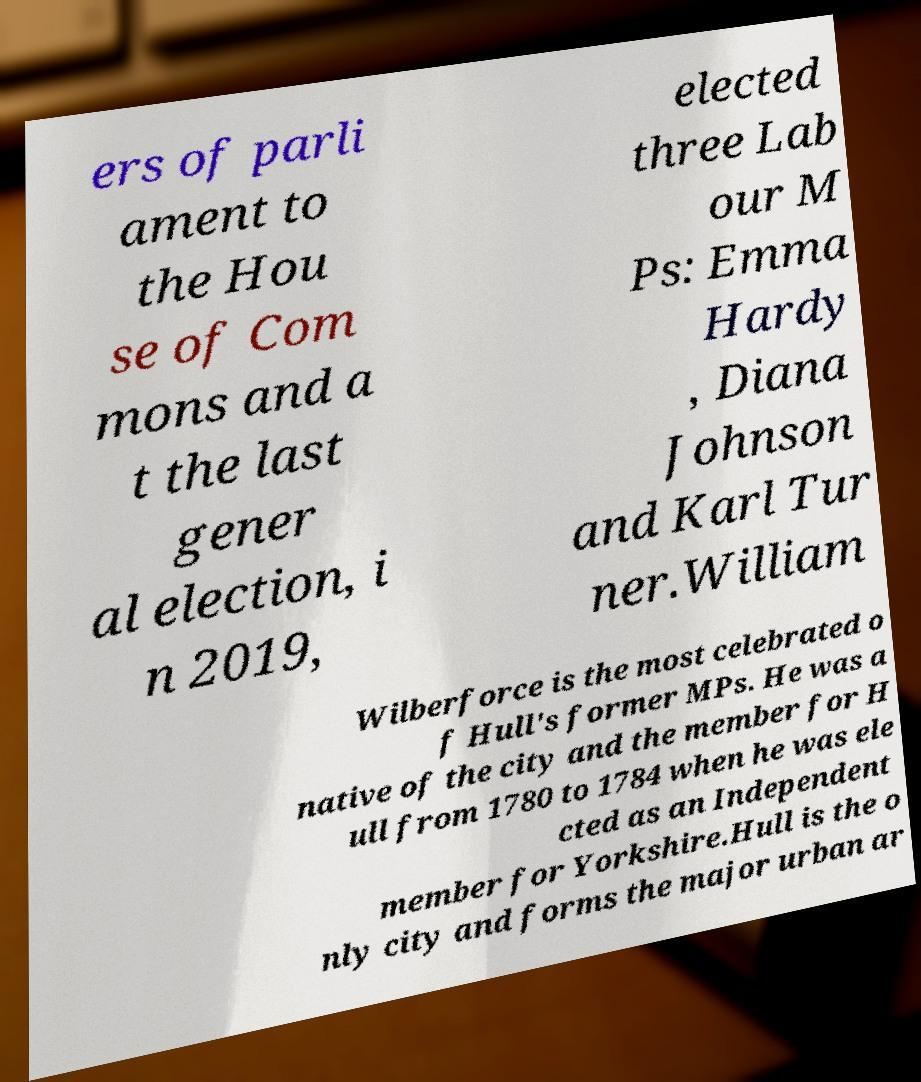Can you accurately transcribe the text from the provided image for me? ers of parli ament to the Hou se of Com mons and a t the last gener al election, i n 2019, elected three Lab our M Ps: Emma Hardy , Diana Johnson and Karl Tur ner.William Wilberforce is the most celebrated o f Hull's former MPs. He was a native of the city and the member for H ull from 1780 to 1784 when he was ele cted as an Independent member for Yorkshire.Hull is the o nly city and forms the major urban ar 